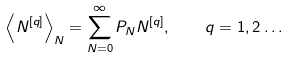Convert formula to latex. <formula><loc_0><loc_0><loc_500><loc_500>\left < N ^ { [ q ] } \right > _ { N } = \sum _ { N = 0 } ^ { \infty } P _ { N } N ^ { [ q ] } , \quad q = 1 , 2 \dots</formula> 